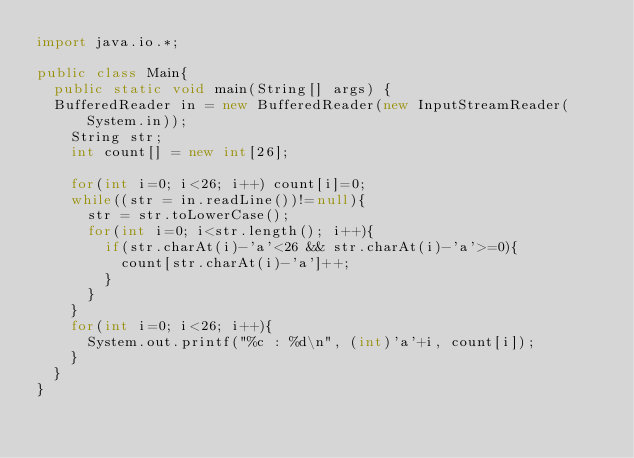Convert code to text. <code><loc_0><loc_0><loc_500><loc_500><_Java_>import java.io.*;

public class Main{
	public static void main(String[] args) {
	BufferedReader in = new BufferedReader(new InputStreamReader(System.in));
		String str;
		int count[] = new int[26];

		for(int i=0; i<26; i++) count[i]=0;
		while((str = in.readLine())!=null){
			str = str.toLowerCase();
			for(int i=0; i<str.length(); i++){
				if(str.charAt(i)-'a'<26 && str.charAt(i)-'a'>=0){
					count[str.charAt(i)-'a']++;
				}
			}
		}
		for(int i=0; i<26; i++){
			System.out.printf("%c : %d\n", (int)'a'+i, count[i]);
		}
	}
}</code> 